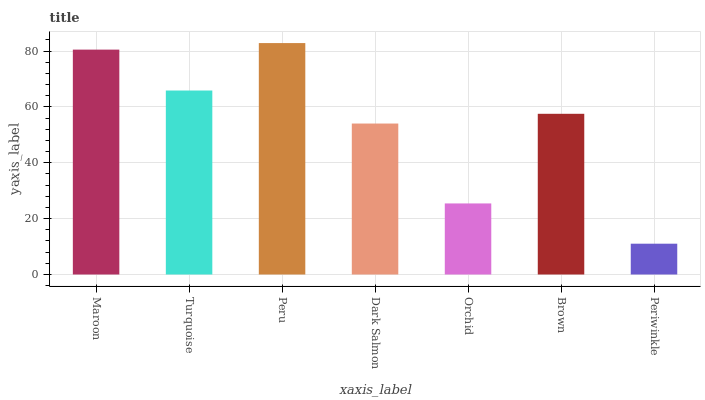Is Periwinkle the minimum?
Answer yes or no. Yes. Is Peru the maximum?
Answer yes or no. Yes. Is Turquoise the minimum?
Answer yes or no. No. Is Turquoise the maximum?
Answer yes or no. No. Is Maroon greater than Turquoise?
Answer yes or no. Yes. Is Turquoise less than Maroon?
Answer yes or no. Yes. Is Turquoise greater than Maroon?
Answer yes or no. No. Is Maroon less than Turquoise?
Answer yes or no. No. Is Brown the high median?
Answer yes or no. Yes. Is Brown the low median?
Answer yes or no. Yes. Is Maroon the high median?
Answer yes or no. No. Is Maroon the low median?
Answer yes or no. No. 